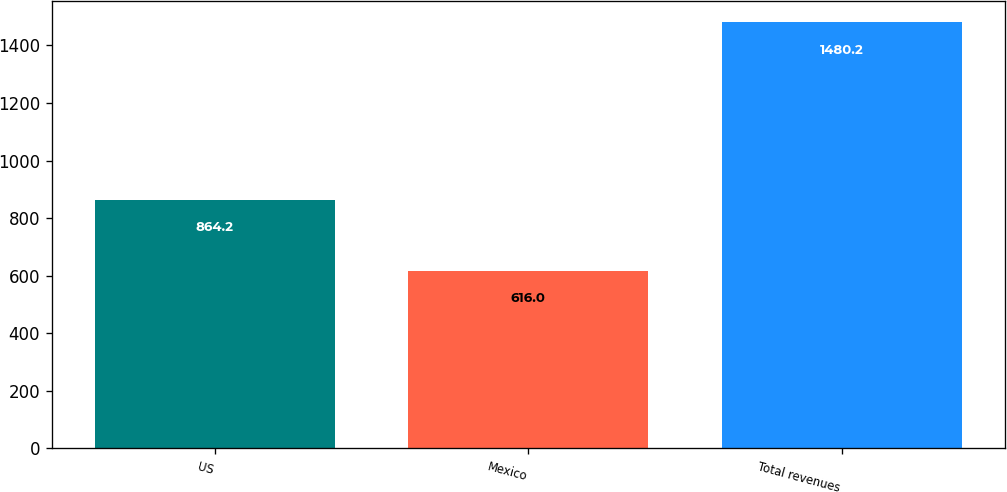Convert chart. <chart><loc_0><loc_0><loc_500><loc_500><bar_chart><fcel>US<fcel>Mexico<fcel>Total revenues<nl><fcel>864.2<fcel>616<fcel>1480.2<nl></chart> 